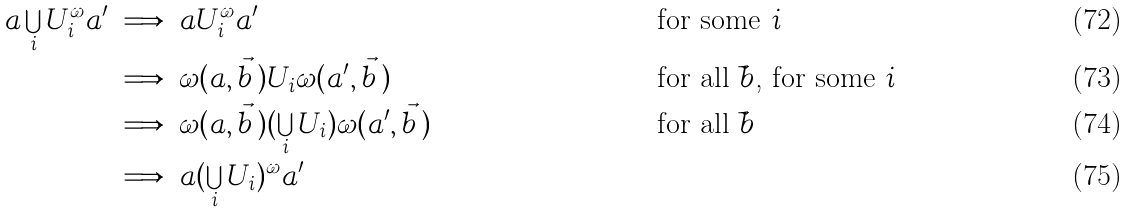Convert formula to latex. <formula><loc_0><loc_0><loc_500><loc_500>a \bigcup _ { i } U _ { i } ^ { \omega } a ^ { \prime } & \implies a U _ { i } ^ { \omega } a ^ { \prime } & & \text {for some $i$} \\ & \implies \omega ( a , \vec { b } \, ) U _ { i } \omega ( a ^ { \prime } , \vec { b } \, ) & & \text {for all $\vec{ }b$, for some $i$} \\ & \implies \omega ( a , \vec { b } \, ) ( \bigcup _ { i } U _ { i } ) \omega ( a ^ { \prime } , \vec { b } \, ) & & \text {for all $\vec{ }b$} \\ & \implies a ( \bigcup _ { i } U _ { i } ) ^ { \omega } a ^ { \prime }</formula> 